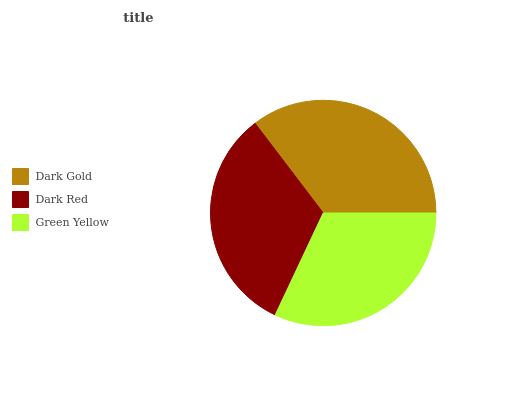Is Green Yellow the minimum?
Answer yes or no. Yes. Is Dark Gold the maximum?
Answer yes or no. Yes. Is Dark Red the minimum?
Answer yes or no. No. Is Dark Red the maximum?
Answer yes or no. No. Is Dark Gold greater than Dark Red?
Answer yes or no. Yes. Is Dark Red less than Dark Gold?
Answer yes or no. Yes. Is Dark Red greater than Dark Gold?
Answer yes or no. No. Is Dark Gold less than Dark Red?
Answer yes or no. No. Is Dark Red the high median?
Answer yes or no. Yes. Is Dark Red the low median?
Answer yes or no. Yes. Is Green Yellow the high median?
Answer yes or no. No. Is Dark Gold the low median?
Answer yes or no. No. 